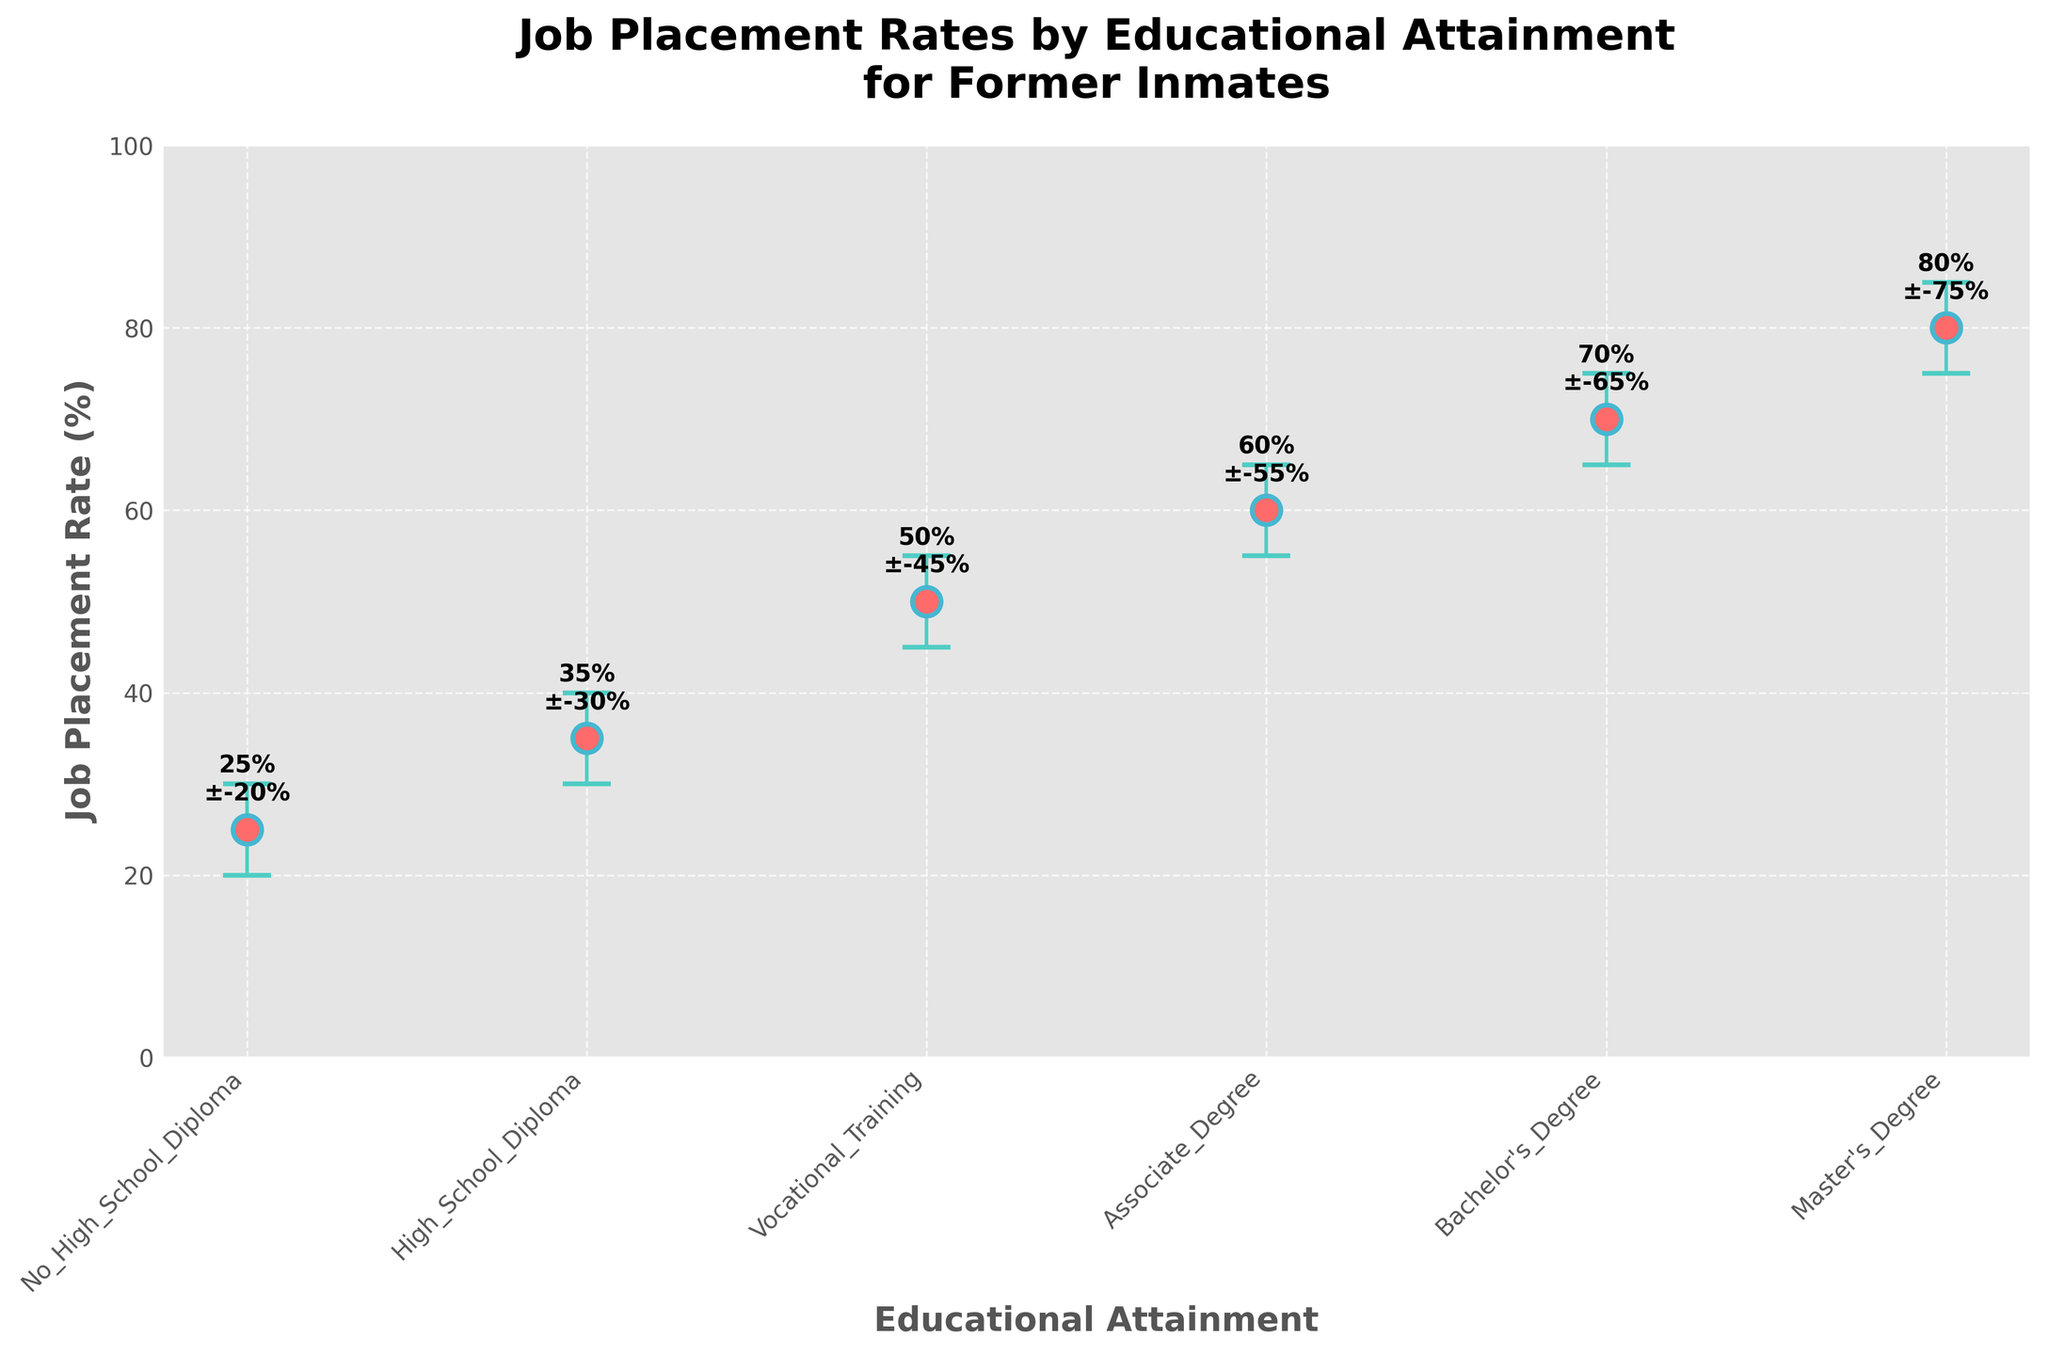What's the title of the figure? The title is written at the top of the figure in the largest and boldest text. It reads: "Job Placement Rates by Educational Attainment for Former Inmates".
Answer: Job Placement Rates by Educational Attainment for Former Inmates What is the job placement rate for those with a Bachelor's Degree? Look for the Bachelor's Degree data point on the x-axis and refer to its corresponding y-axis value. The job placement rate is labeled at 70%.
Answer: 70% How does the job placement rate change as educational attainment increases from No High School Diploma to a Master's Degree? Observe the slope of the plotted points from left to right. Generally, the job placement rate increases as educational attainment increases, with specific rates provided for each educational level.
Answer: It increases Which educational attainment level has the highest job placement rate? Check all the plotted points and their corresponding y-axis values to identify the highest. The Master's Degree has the highest job placement rate at 80%.
Answer: Master's Degree What is the difference in job placement rates between those with an Associate Degree and a Vocational Training certificate? Locate the specific points for Associate Degree and Vocational Training. Subtract the job placement rate of Vocational Training (50%) from that of Associate Degree (60%).
Answer: 10% What is the range of job placement rates for individuals with a High School Diploma? The lower and upper error bars provide this information. The range is the difference between the upper (40%) and lower bounds (30%).
Answer: 10% How does the error bar for Vocational Training compare to that of Bachelor's Degree? Compare the length of the vertical error bars for both. The Vocational Training error bar ranges from 45% to 55%, while the Bachelor's Degree ranges from 65% to 75%. Both have the same error range of ±5%.
Answer: They are equal Which educational level has the widest error bar range? Check each data point's error bars and determine which one spans the greatest range. Each educational level's job placement rate range is consistently ±5%, so they are equal.
Answer: They are equal Is there any overlap in the job placement rates between High School Diploma and Vocational Training? The error bar for High School Diploma extends from 30% to 40%, and for Vocational Training, it extends from 45% to 55%. Since there is no intersection, there is no overlap.
Answer: No Does an Associate Degree provide significantly better job placement rates compared to only having a High School Diploma? Compare the error bars for both levels. The High School Diploma ranges between 30% and 40%, while the Associate Degree ranges between 55% and 65%. There is no overlap, indicating a significant difference.
Answer: Yes 